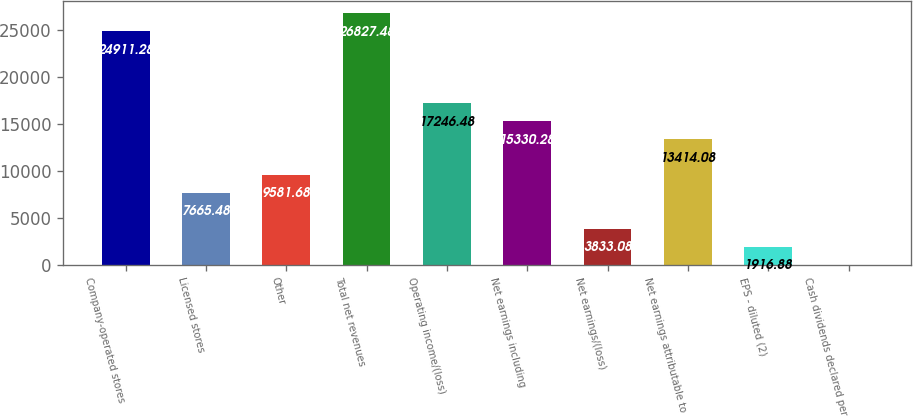<chart> <loc_0><loc_0><loc_500><loc_500><bar_chart><fcel>Company-operated stores<fcel>Licensed stores<fcel>Other<fcel>Total net revenues<fcel>Operating income/(loss)<fcel>Net earnings including<fcel>Net earnings/(loss)<fcel>Net earnings attributable to<fcel>EPS - diluted (2)<fcel>Cash dividends declared per<nl><fcel>24911.3<fcel>7665.48<fcel>9581.68<fcel>26827.5<fcel>17246.5<fcel>15330.3<fcel>3833.08<fcel>13414.1<fcel>1916.88<fcel>0.68<nl></chart> 